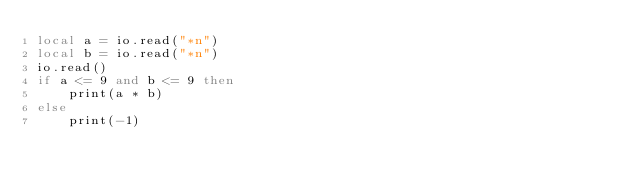Convert code to text. <code><loc_0><loc_0><loc_500><loc_500><_Lua_>local a = io.read("*n")
local b = io.read("*n")
io.read()
if a <= 9 and b <= 9 then
	print(a * b)
else
	print(-1)</code> 